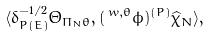Convert formula to latex. <formula><loc_0><loc_0><loc_500><loc_500>\langle \delta _ { P ( E ) } ^ { - 1 / 2 } \Theta _ { \Pi _ { N } \theta } , ( \, ^ { w , \theta } \phi ) ^ { ( P ) } \widehat { \chi } _ { N } \rangle ,</formula> 